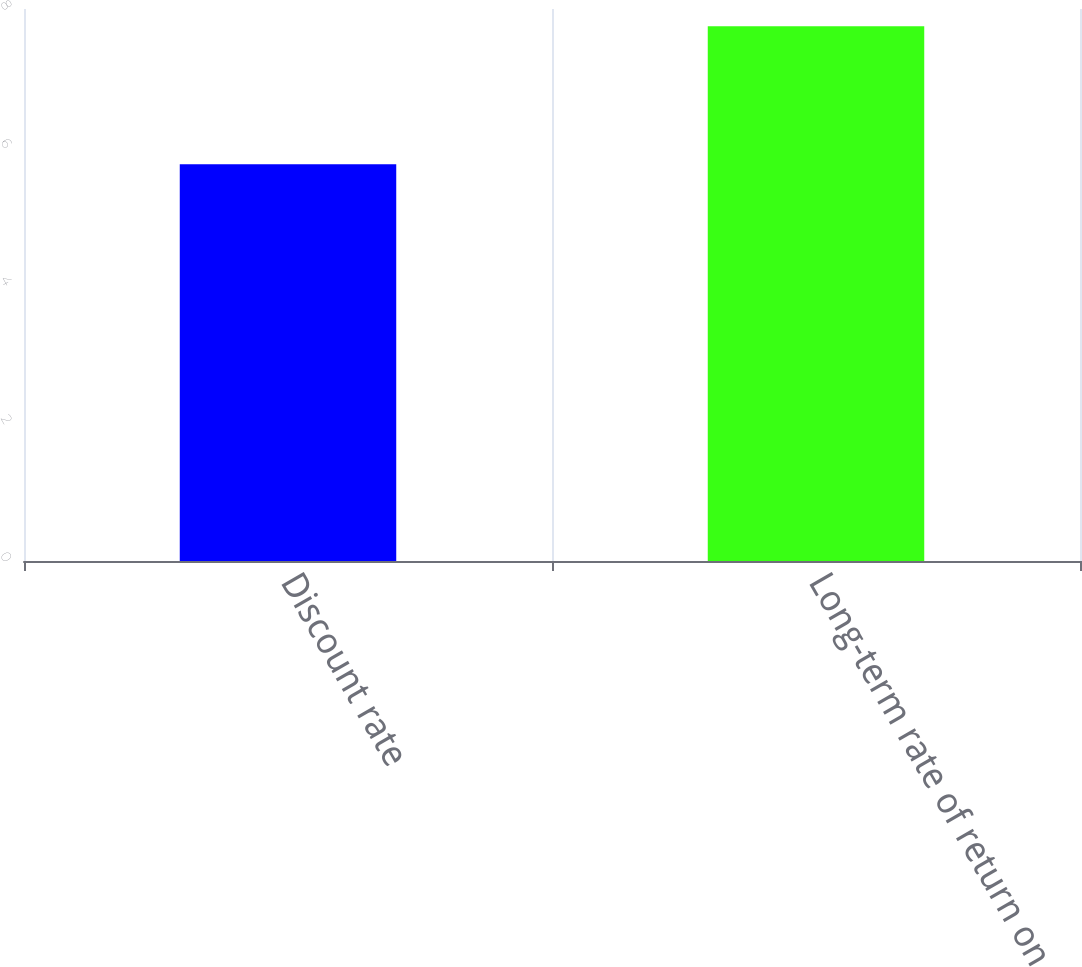Convert chart to OTSL. <chart><loc_0><loc_0><loc_500><loc_500><bar_chart><fcel>Discount rate<fcel>Long-term rate of return on<nl><fcel>5.75<fcel>7.75<nl></chart> 